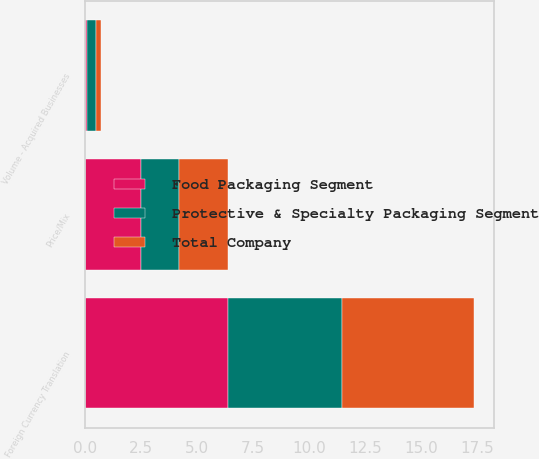Convert chart. <chart><loc_0><loc_0><loc_500><loc_500><stacked_bar_chart><ecel><fcel>Volume - Acquired Businesses<fcel>Price/Mix<fcel>Foreign Currency Translation<nl><fcel>Food Packaging Segment<fcel>0.1<fcel>2.5<fcel>6.4<nl><fcel>Protective & Specialty Packaging Segment<fcel>0.4<fcel>1.7<fcel>5.1<nl><fcel>Total Company<fcel>0.2<fcel>2.2<fcel>5.9<nl></chart> 